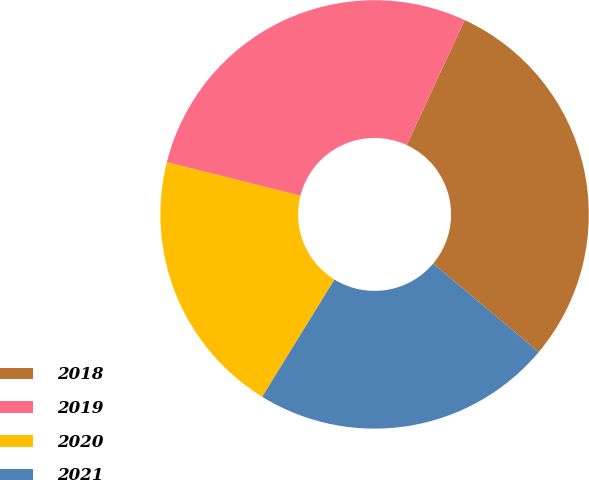Convert chart. <chart><loc_0><loc_0><loc_500><loc_500><pie_chart><fcel>2018<fcel>2019<fcel>2020<fcel>2021<nl><fcel>29.2%<fcel>27.99%<fcel>20.13%<fcel>22.68%<nl></chart> 